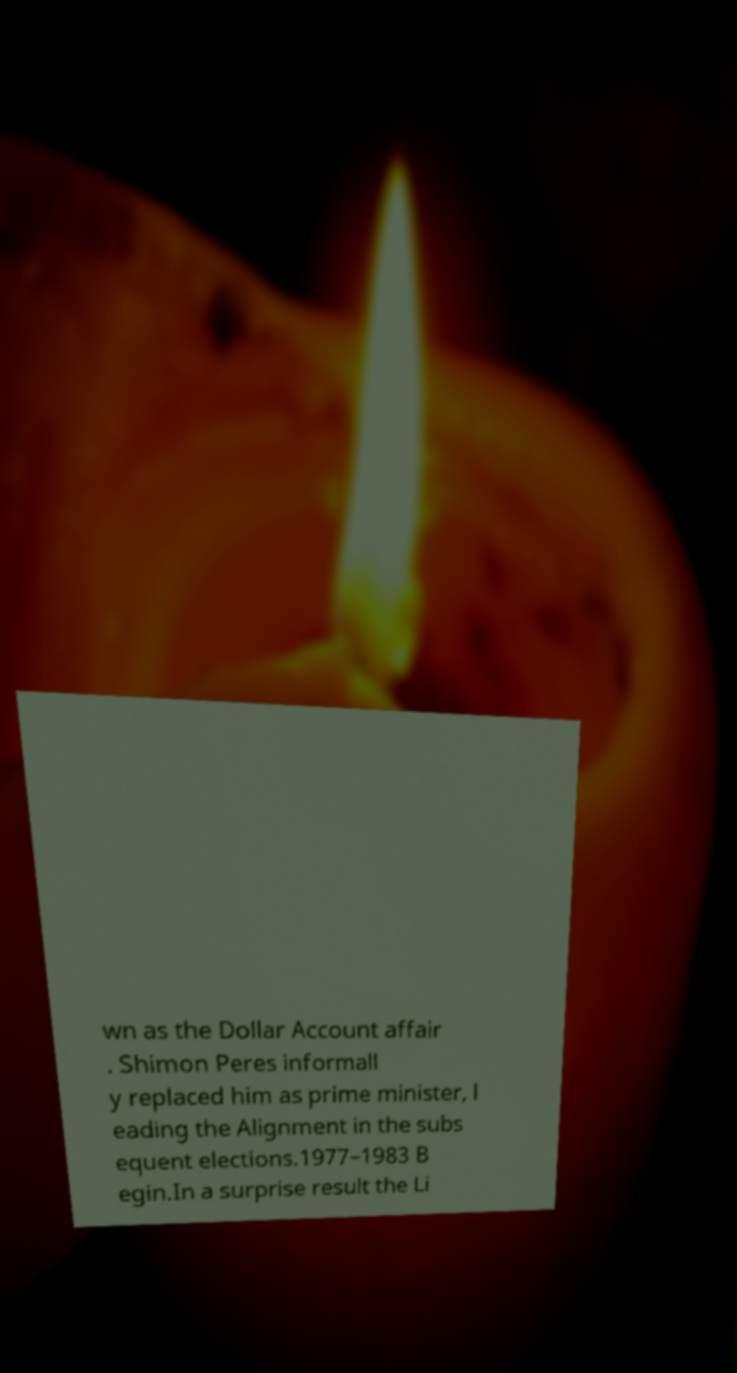What messages or text are displayed in this image? I need them in a readable, typed format. wn as the Dollar Account affair . Shimon Peres informall y replaced him as prime minister, l eading the Alignment in the subs equent elections.1977–1983 B egin.In a surprise result the Li 